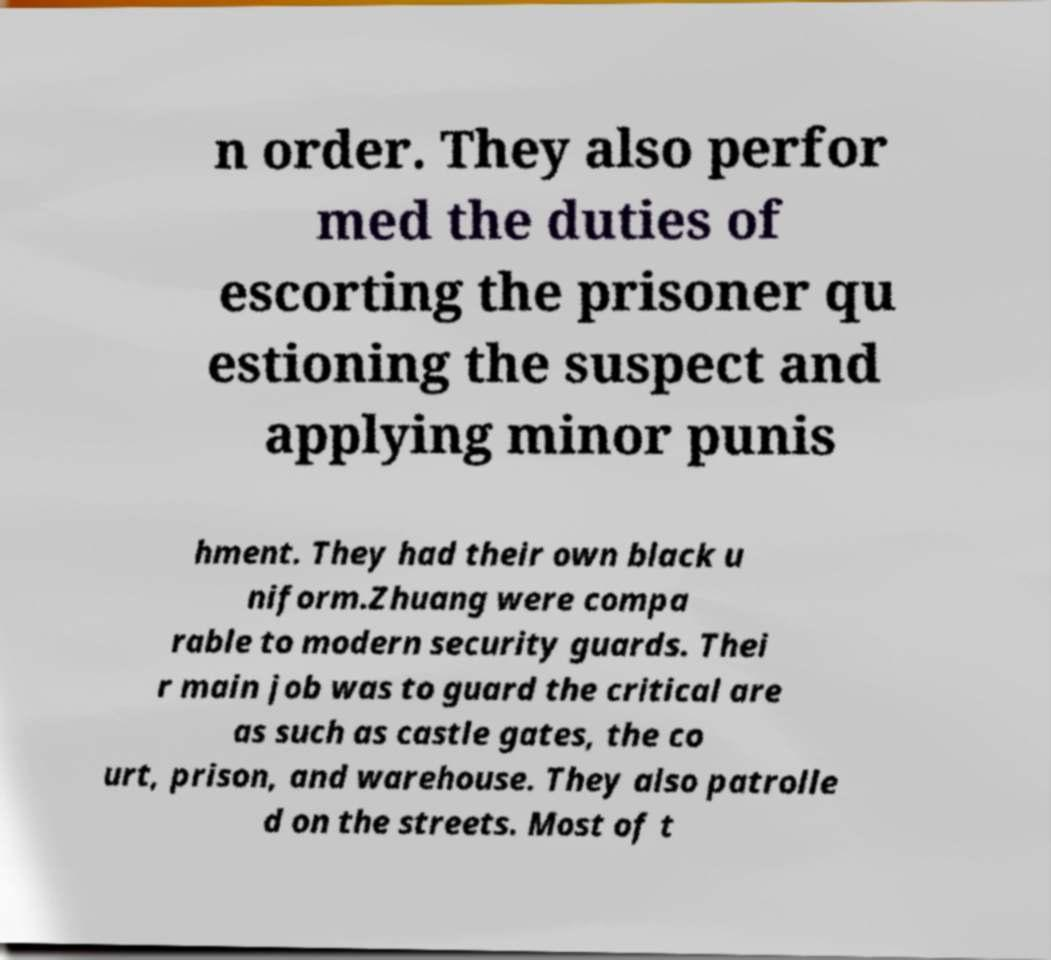What messages or text are displayed in this image? I need them in a readable, typed format. n order. They also perfor med the duties of escorting the prisoner qu estioning the suspect and applying minor punis hment. They had their own black u niform.Zhuang were compa rable to modern security guards. Thei r main job was to guard the critical are as such as castle gates, the co urt, prison, and warehouse. They also patrolle d on the streets. Most of t 